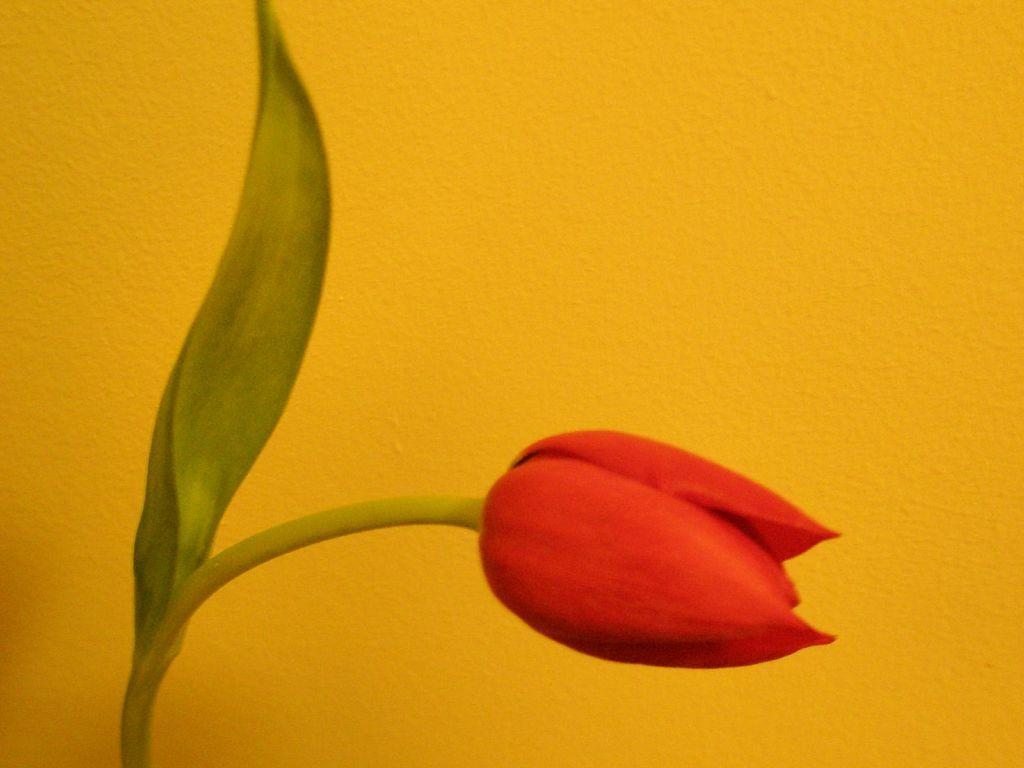What is the main subject of the image? There is a flower in the image. What part of the flower is mentioned in the facts? The flower has a leaf. What color is the background of the image? The background of the image is yellow in color. What type of joke is being told by the flower in the image? There is no joke being told by the flower in the image, as flowers do not have the ability to tell jokes. 